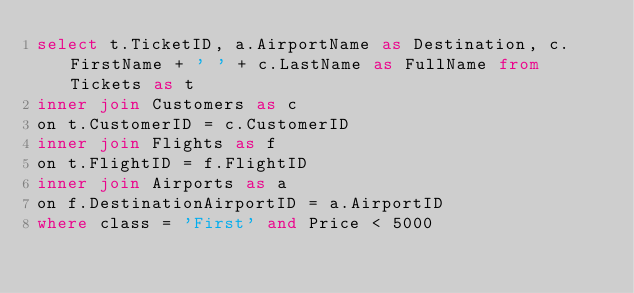<code> <loc_0><loc_0><loc_500><loc_500><_SQL_>select t.TicketID, a.AirportName as Destination, c.FirstName + ' ' + c.LastName as FullName from Tickets as t
inner join Customers as c
on t.CustomerID = c.CustomerID
inner join Flights as f
on t.FlightID = f.FlightID
inner join Airports as a
on f.DestinationAirportID = a.AirportID
where class = 'First' and Price < 5000</code> 